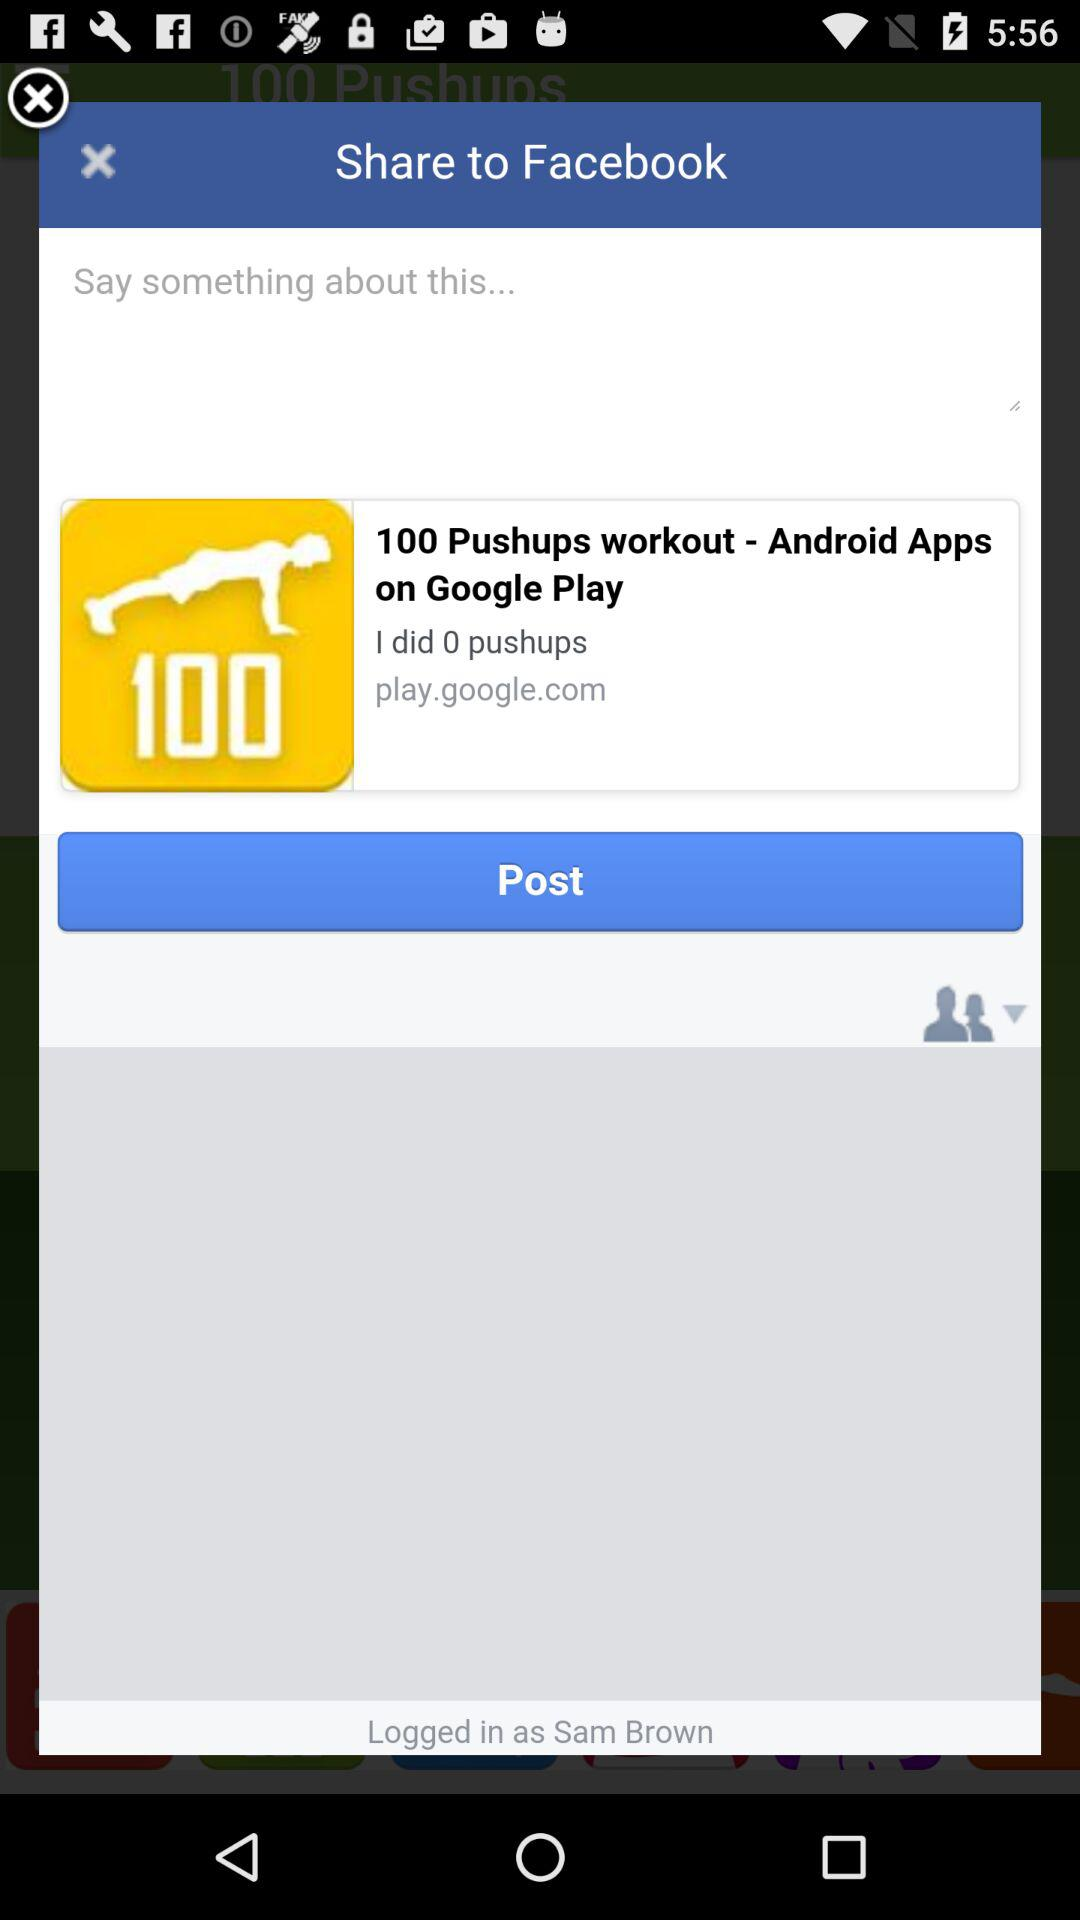How many people are logged into this account?
Answer the question using a single word or phrase. 1 